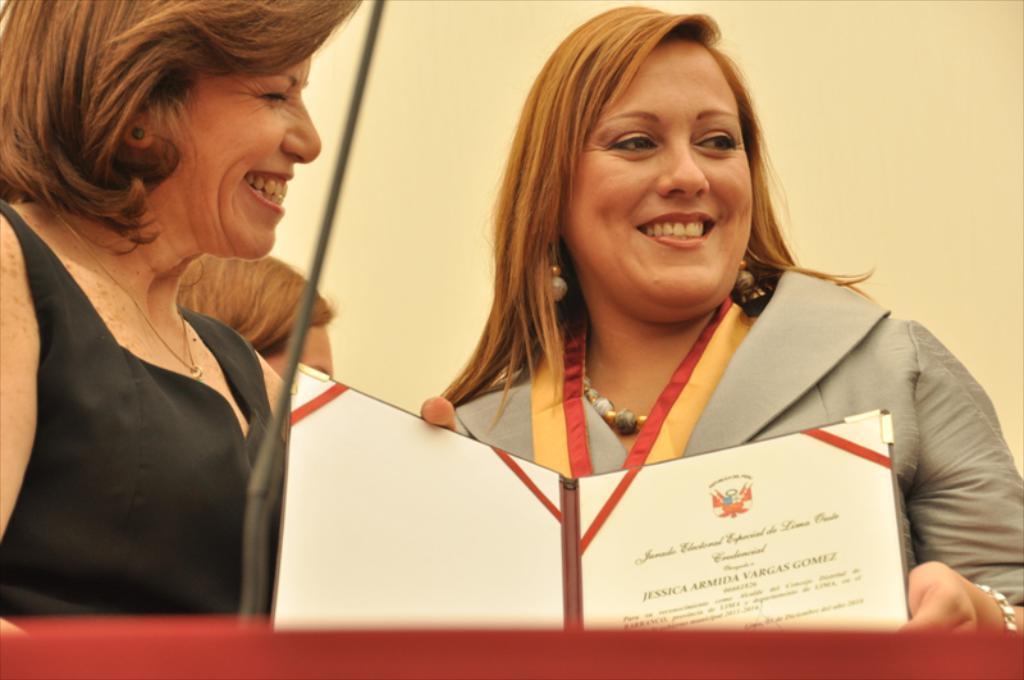Can you describe this image briefly? In this image there are two women standing. They are smiling. The woman to the right is holding a certificate in her hand. There is text on the certificate. Behind them there is a wall. In the foreground there is a rod. 